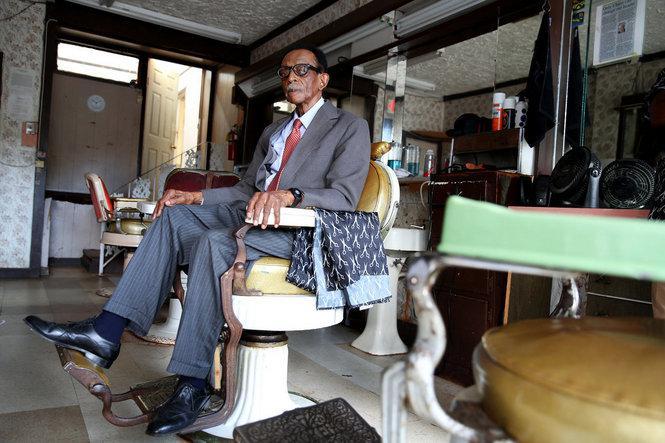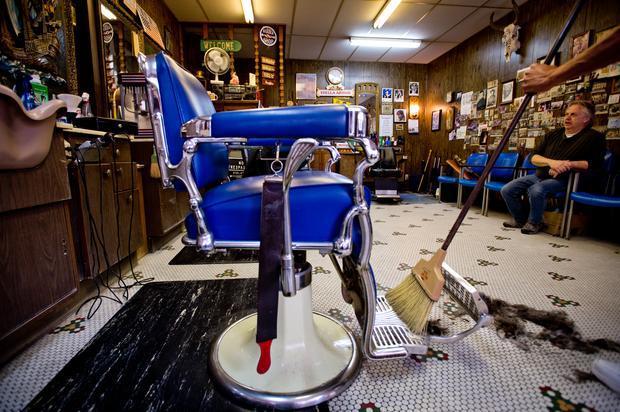The first image is the image on the left, the second image is the image on the right. For the images shown, is this caption "In at least one image there is a single man in a suit and tie sitting in a barber chair." true? Answer yes or no. Yes. The first image is the image on the left, the second image is the image on the right. Considering the images on both sides, is "The left image shows an older black man in suit, tie and eyeglasses, sitting on a white barber chair." valid? Answer yes or no. Yes. 